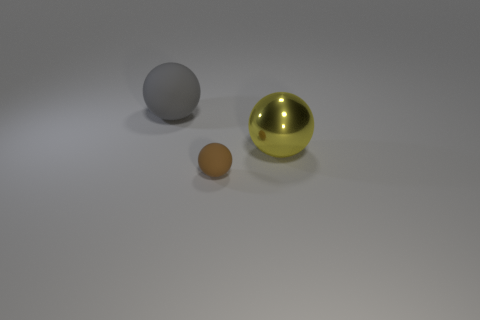Subtract all big spheres. How many spheres are left? 1 Subtract all yellow spheres. How many spheres are left? 2 Subtract 1 balls. How many balls are left? 2 Add 1 small brown objects. How many objects exist? 4 Subtract 0 blue cylinders. How many objects are left? 3 Subtract all green balls. Subtract all green cylinders. How many balls are left? 3 Subtract all gray blocks. How many red balls are left? 0 Subtract all tiny cyan shiny balls. Subtract all big objects. How many objects are left? 1 Add 2 small brown rubber things. How many small brown rubber things are left? 3 Add 1 blue things. How many blue things exist? 1 